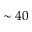Convert formula to latex. <formula><loc_0><loc_0><loc_500><loc_500>\sim 4 0</formula> 